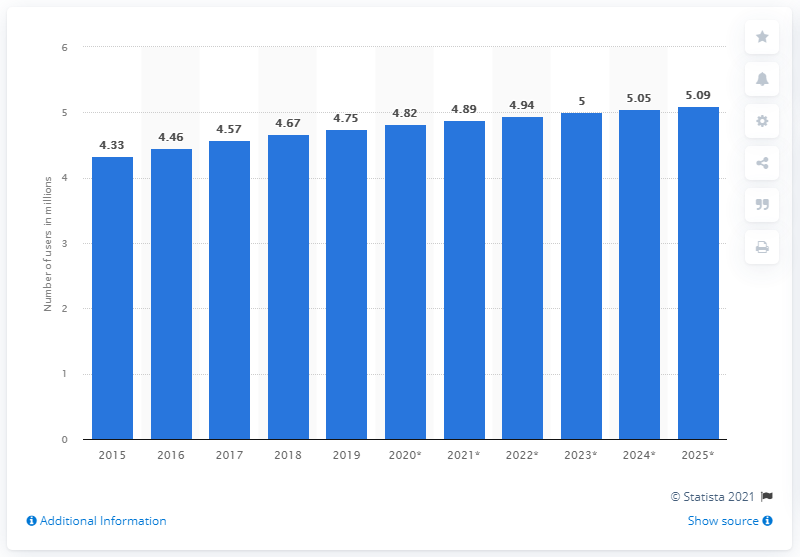Indicate a few pertinent items in this graphic. The projected number of internet users in Singapore in 2025 is expected to be approximately 4.82 million. In 2019, there were 4.82 people accessing the internet in Singapore. 